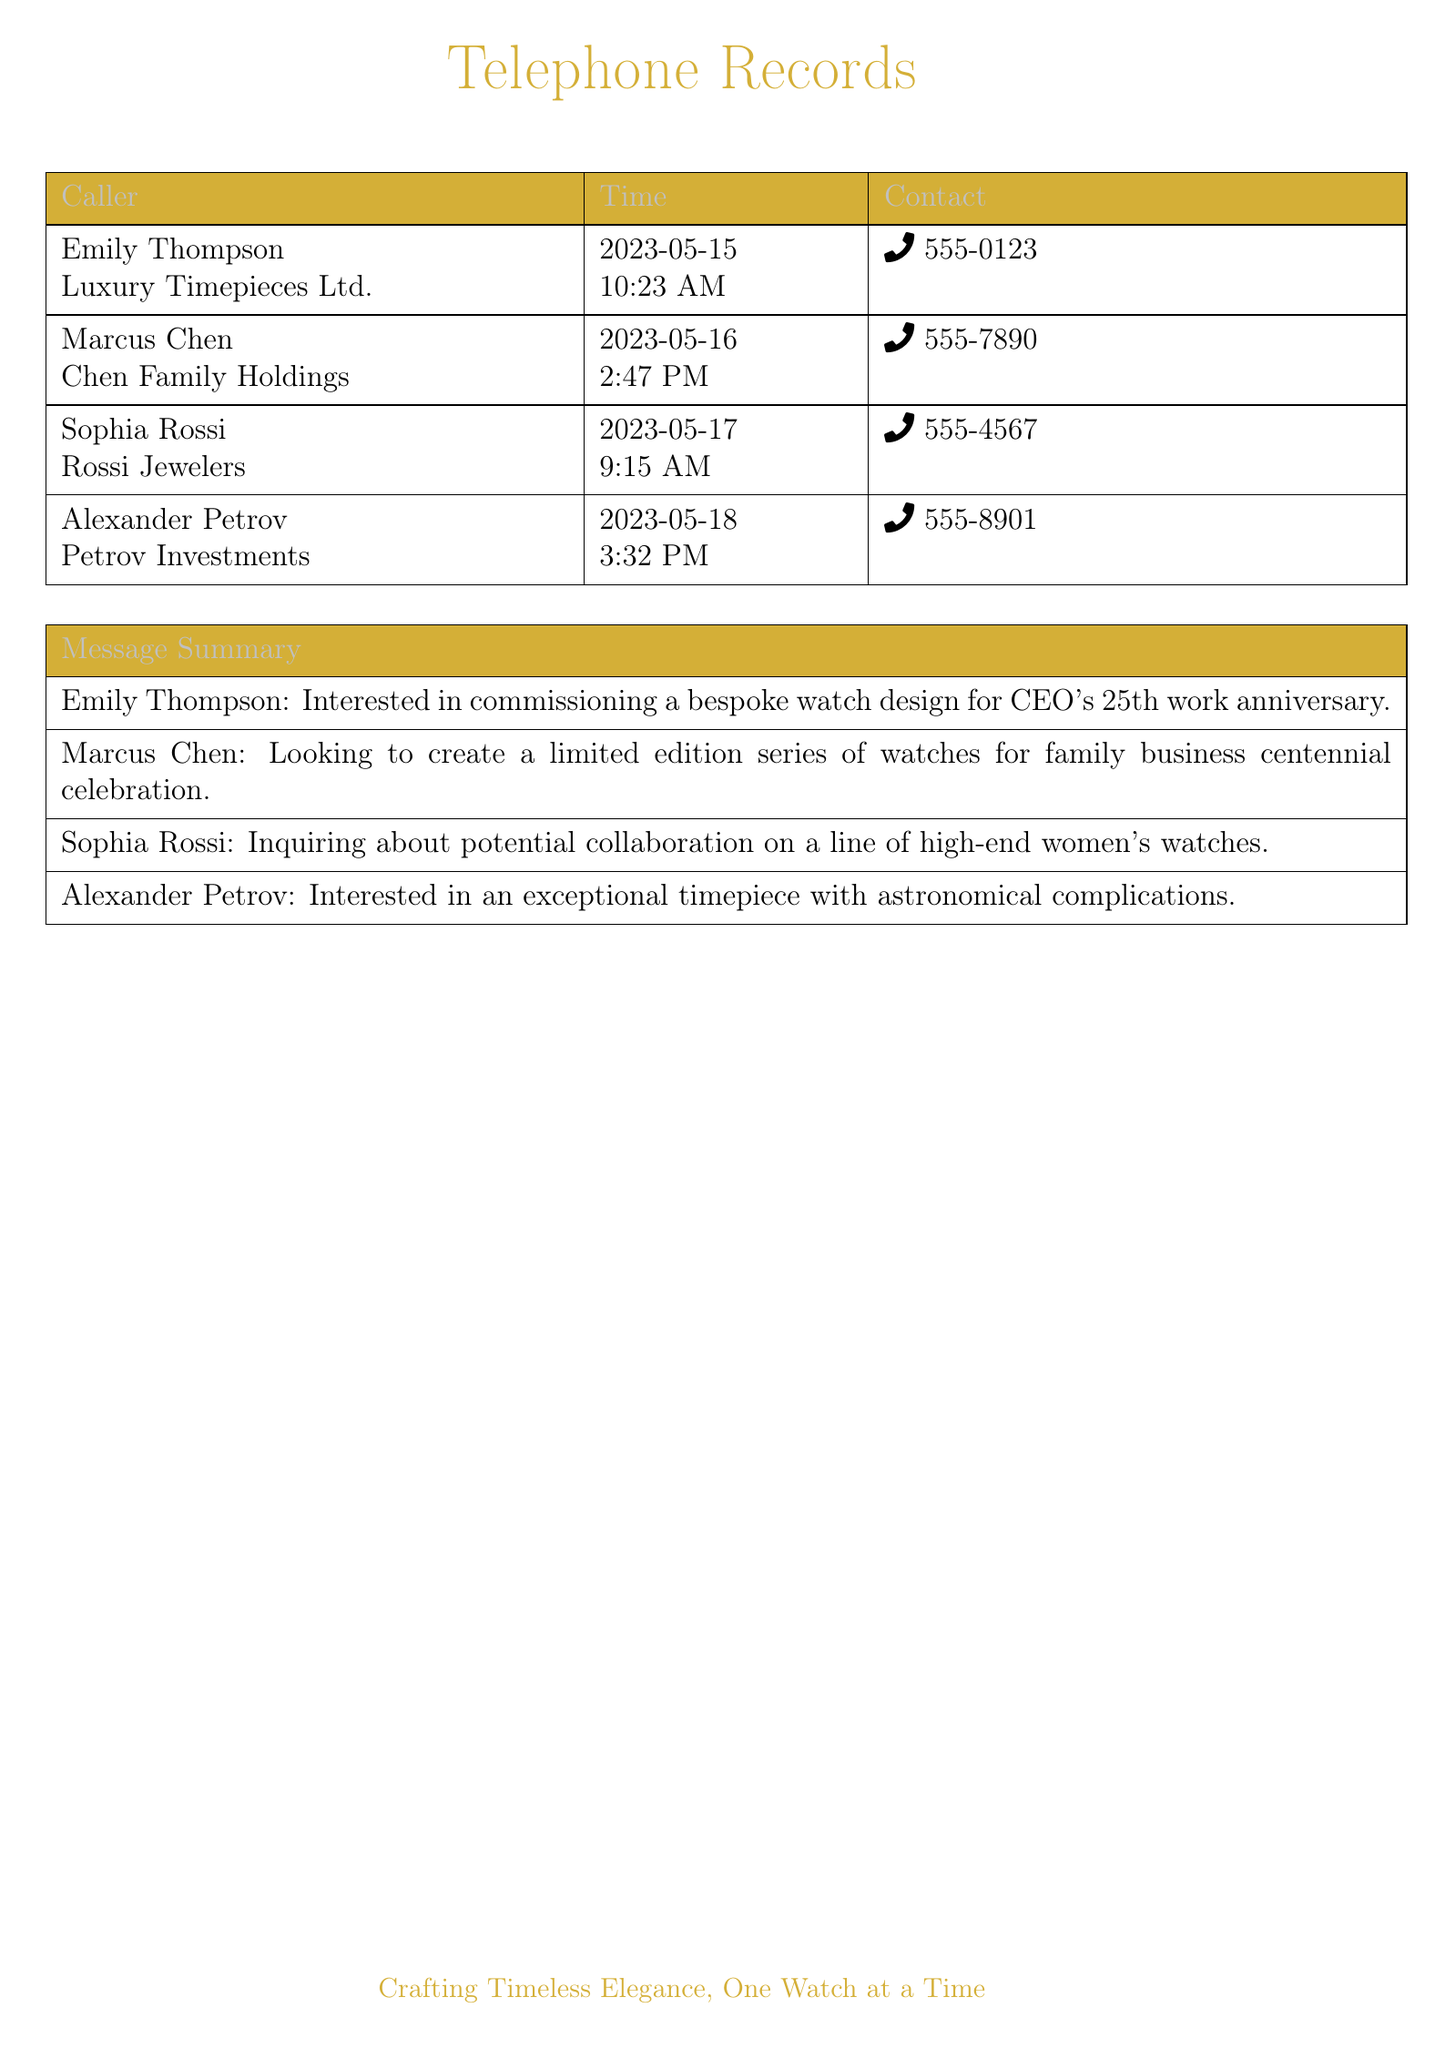What is the name of the caller from Luxury Timepieces Ltd.? The caller from Luxury Timepieces Ltd. is Emily Thompson.
Answer: Emily Thompson What is the date of Marcus Chen's call? The date of Marcus Chen's call is mentioned in the document, which is 2023-05-16.
Answer: 2023-05-16 At what time did Alexander Petrov make his call? The time Alexander Petrov made his call is documented as 3:32 PM.
Answer: 3:32 PM What type of watch does Sophia Rossi want to collaborate on? Sophia Rossi is inquiring about a line of high-end women's watches.
Answer: high-end women's watches Which company's call was made on May 17? The call made on May 17 is from Rossi Jewelers.
Answer: Rossi Jewelers What occasion is Emily Thompson's commission for a watch? Emily Thompson is commissioning a bespoke watch design for a CEO's 25th work anniversary.
Answer: CEO's 25th work anniversary What is the focus of Marcus Chen's watch project? Marcus Chen is looking to create a limited edition series of watches for a family business centennial celebration.
Answer: limited edition series for family business centennial celebration Which caller expressed interest in astronomical complications? The caller interested in astronomical complications is Alexander Petrov.
Answer: Alexander Petrov 